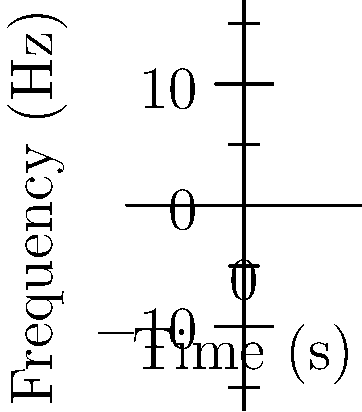Based on the spectrogram of a singer's performance from "The Voice," what can you conclude about their vocal range and pitch accuracy? To analyze the vocal range and pitch accuracy from this spectrogram:

1. Vocal Range:
   - The lowest visible frequency is approximately 200 Hz.
   - The highest visible frequency is around 600 Hz.
   - The vocal range is indicated by the arrow on the right, spanning from 200 Hz to 600 Hz.

2. Pitch Accuracy:
   - The three curved lines represent the fundamental frequency and harmonics of the singer's voice.
   - Perfectly straight horizontal lines would indicate perfect pitch.
   - The waviness in these lines suggests some pitch variation.
   - Vertical dashed lines at 1s, 2s, and 3s mark specific points to assess pitch accuracy:
     a) At 1s and 3s: Moderate deviation from the central frequency.
     b) At 2s: Larger deviation, indicating less accurate pitch.

3. Overall Assessment:
   - The vocal range of approximately 400 Hz (from 200 Hz to 600 Hz) is moderate, typical for many singers.
   - Pitch accuracy is variable, with moments of good control (less wavy sections) and moments of less accuracy (more wavy sections, especially around 2s).

Conclusion: The singer demonstrates a moderate vocal range with variable pitch accuracy, showing potential but room for improvement in pitch control.
Answer: Moderate range (400 Hz); variable pitch accuracy 